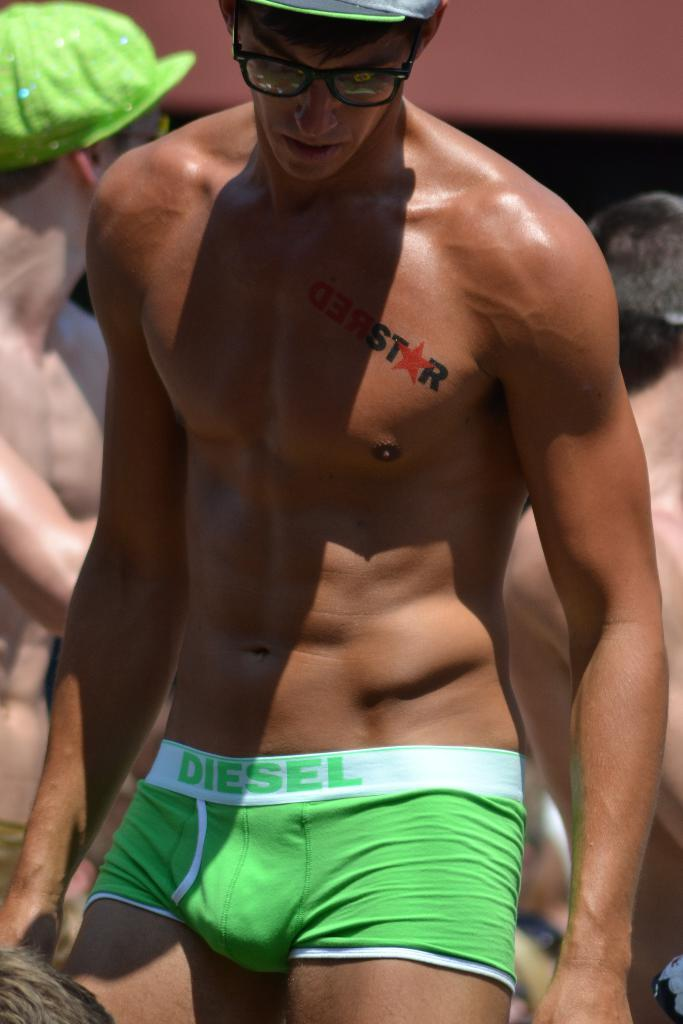<image>
Write a terse but informative summary of the picture. Man with a tattoo on his chest which says Star. 